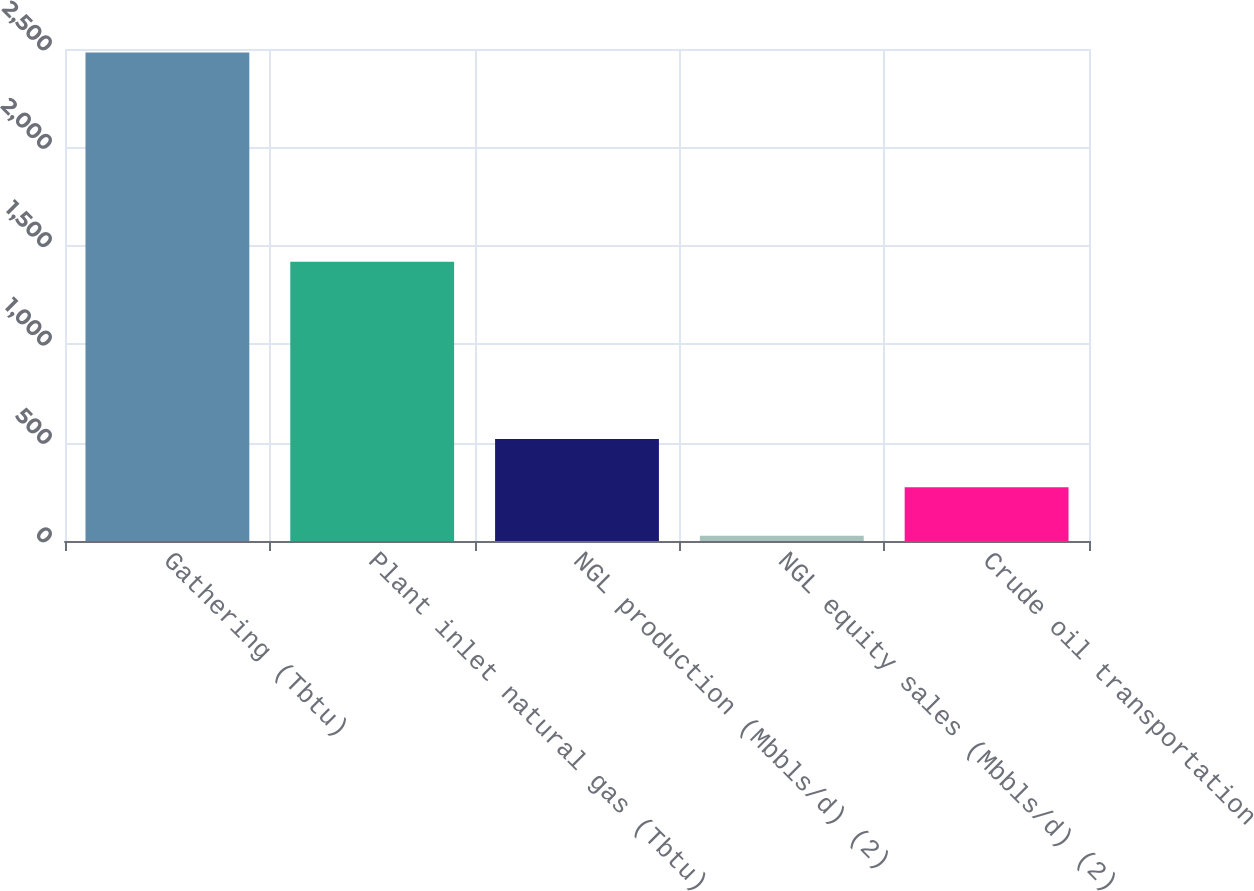Convert chart. <chart><loc_0><loc_0><loc_500><loc_500><bar_chart><fcel>Gathering (Tbtu)<fcel>Plant inlet natural gas (Tbtu)<fcel>NGL production (Mbbls/d) (2)<fcel>NGL equity sales (Mbbls/d) (2)<fcel>Crude oil transportation<nl><fcel>2482<fcel>1419<fcel>518<fcel>27<fcel>272.5<nl></chart> 